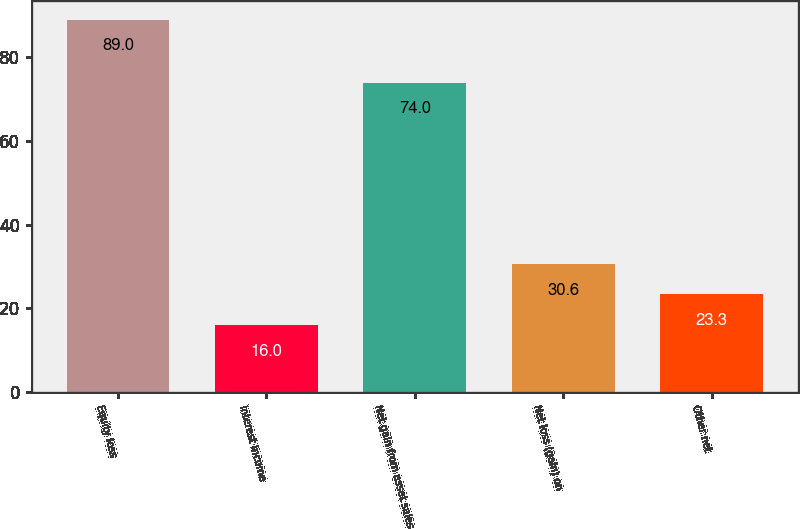Convert chart to OTSL. <chart><loc_0><loc_0><loc_500><loc_500><bar_chart><fcel>Equity loss<fcel>Interest income<fcel>Net gain from asset sales<fcel>Net loss (gain) on<fcel>Other net<nl><fcel>89<fcel>16<fcel>74<fcel>30.6<fcel>23.3<nl></chart> 